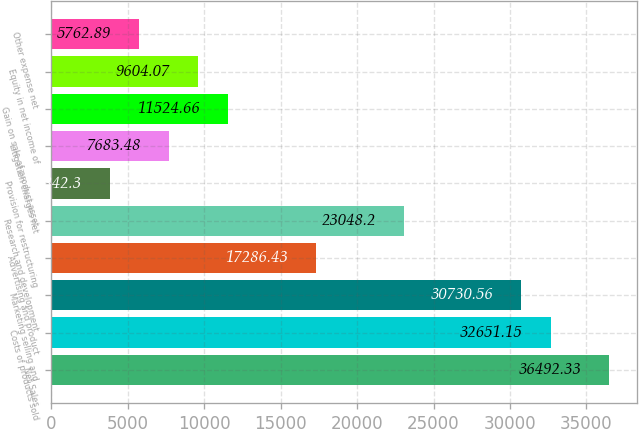<chart> <loc_0><loc_0><loc_500><loc_500><bar_chart><fcel>Net Sales<fcel>Costs of products sold<fcel>Marketing selling and<fcel>Advertising and product<fcel>Research and development<fcel>Provision for restructuring<fcel>Litigation charges net<fcel>Gain on sale of product asset<fcel>Equity in net income of<fcel>Other expense net<nl><fcel>36492.3<fcel>32651.2<fcel>30730.6<fcel>17286.4<fcel>23048.2<fcel>3842.3<fcel>7683.48<fcel>11524.7<fcel>9604.07<fcel>5762.89<nl></chart> 